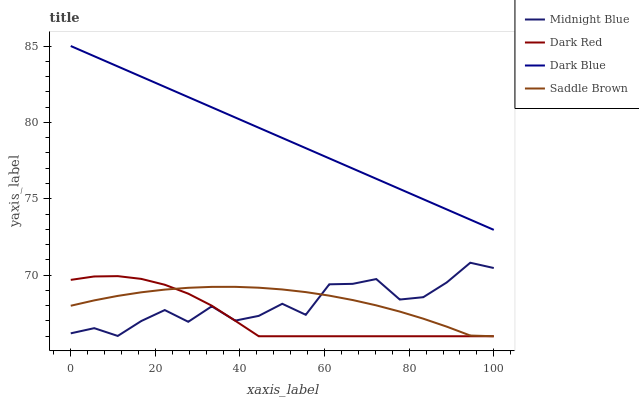Does Dark Red have the minimum area under the curve?
Answer yes or no. Yes. Does Dark Blue have the maximum area under the curve?
Answer yes or no. Yes. Does Midnight Blue have the minimum area under the curve?
Answer yes or no. No. Does Midnight Blue have the maximum area under the curve?
Answer yes or no. No. Is Dark Blue the smoothest?
Answer yes or no. Yes. Is Midnight Blue the roughest?
Answer yes or no. Yes. Is Dark Red the smoothest?
Answer yes or no. No. Is Dark Red the roughest?
Answer yes or no. No. Does Saddle Brown have the lowest value?
Answer yes or no. Yes. Does Midnight Blue have the lowest value?
Answer yes or no. No. Does Dark Blue have the highest value?
Answer yes or no. Yes. Does Dark Red have the highest value?
Answer yes or no. No. Is Dark Red less than Dark Blue?
Answer yes or no. Yes. Is Dark Blue greater than Saddle Brown?
Answer yes or no. Yes. Does Saddle Brown intersect Dark Red?
Answer yes or no. Yes. Is Saddle Brown less than Dark Red?
Answer yes or no. No. Is Saddle Brown greater than Dark Red?
Answer yes or no. No. Does Dark Red intersect Dark Blue?
Answer yes or no. No. 